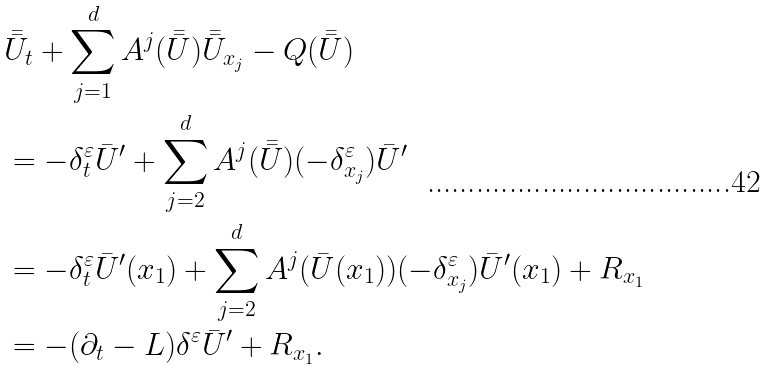<formula> <loc_0><loc_0><loc_500><loc_500>& \bar { \bar { U } } _ { t } + \sum _ { j = 1 } ^ { d } A ^ { j } ( \bar { \bar { U } } ) \bar { \bar { U } } _ { x _ { j } } - Q ( \bar { \bar { U } } ) \\ & = - \delta ^ { \varepsilon } _ { t } \bar { U } ^ { \prime } + \sum _ { j = 2 } ^ { d } A ^ { j } ( \bar { \bar { U } } ) ( - \delta ^ { \varepsilon } _ { x _ { j } } ) \bar { U } ^ { \prime } \\ & = - \delta ^ { \varepsilon } _ { t } \bar { U } ^ { \prime } ( x _ { 1 } ) + \sum _ { j = 2 } ^ { d } A ^ { j } ( \bar { U } ( x _ { 1 } ) ) ( - \delta ^ { \varepsilon } _ { x _ { j } } ) \bar { U } ^ { \prime } ( x _ { 1 } ) + R _ { x _ { 1 } } \\ & = - ( \partial _ { t } - L ) \delta ^ { \varepsilon } \bar { U } ^ { \prime } + R _ { x _ { 1 } } .</formula> 